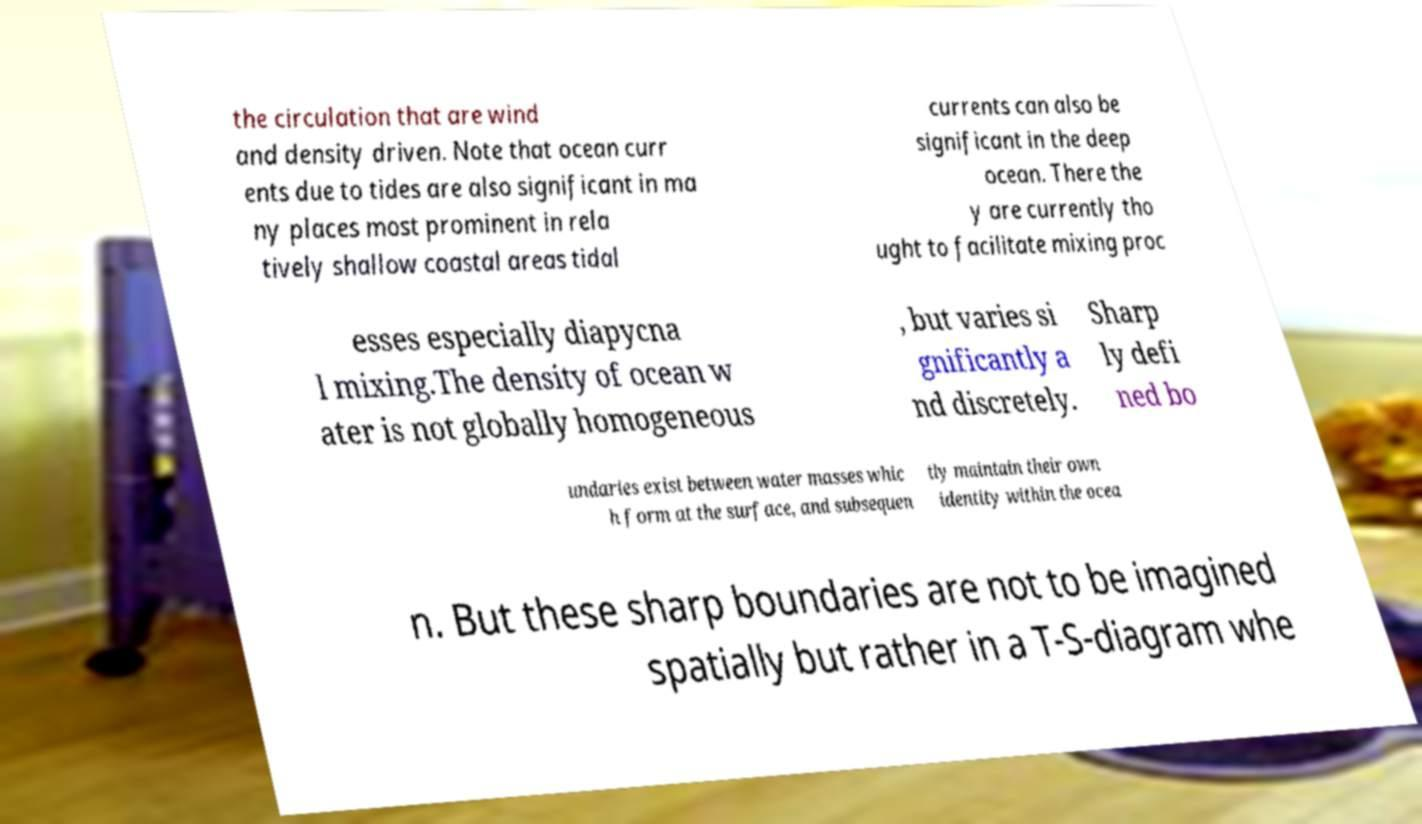Please read and relay the text visible in this image. What does it say? the circulation that are wind and density driven. Note that ocean curr ents due to tides are also significant in ma ny places most prominent in rela tively shallow coastal areas tidal currents can also be significant in the deep ocean. There the y are currently tho ught to facilitate mixing proc esses especially diapycna l mixing.The density of ocean w ater is not globally homogeneous , but varies si gnificantly a nd discretely. Sharp ly defi ned bo undaries exist between water masses whic h form at the surface, and subsequen tly maintain their own identity within the ocea n. But these sharp boundaries are not to be imagined spatially but rather in a T-S-diagram whe 